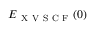<formula> <loc_0><loc_0><loc_500><loc_500>E _ { X V S C F } ( 0 )</formula> 